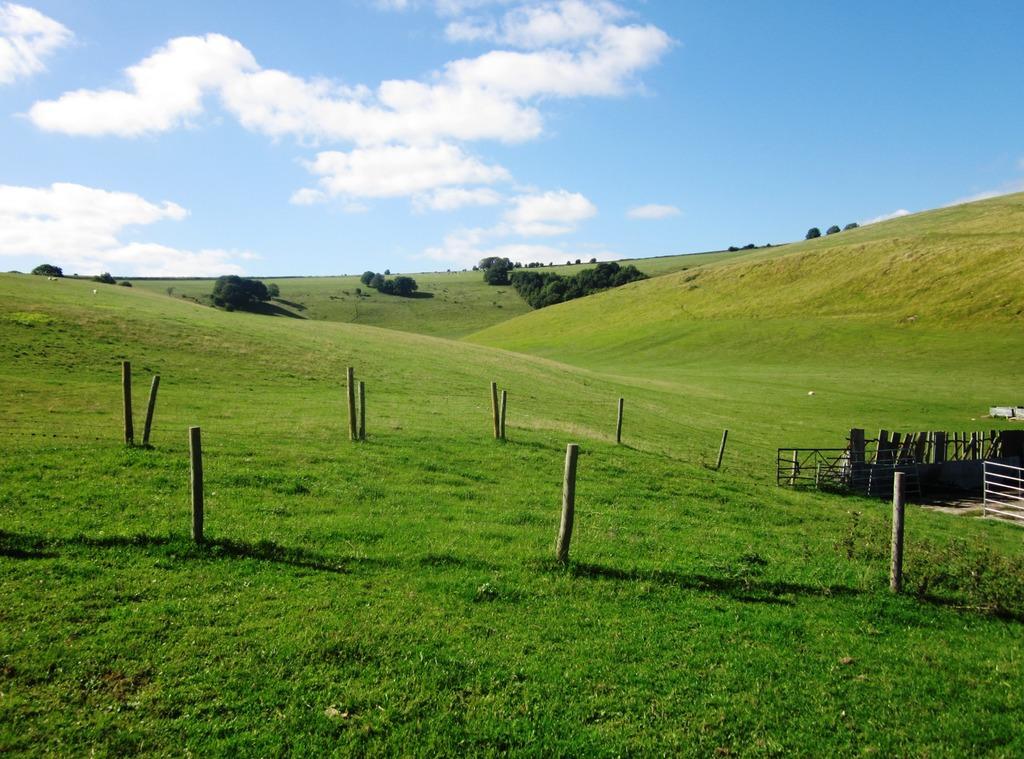Please provide a concise description of this image. In this image there is a grassland wooden poles, fencing, in the background there are trees and the sky. 